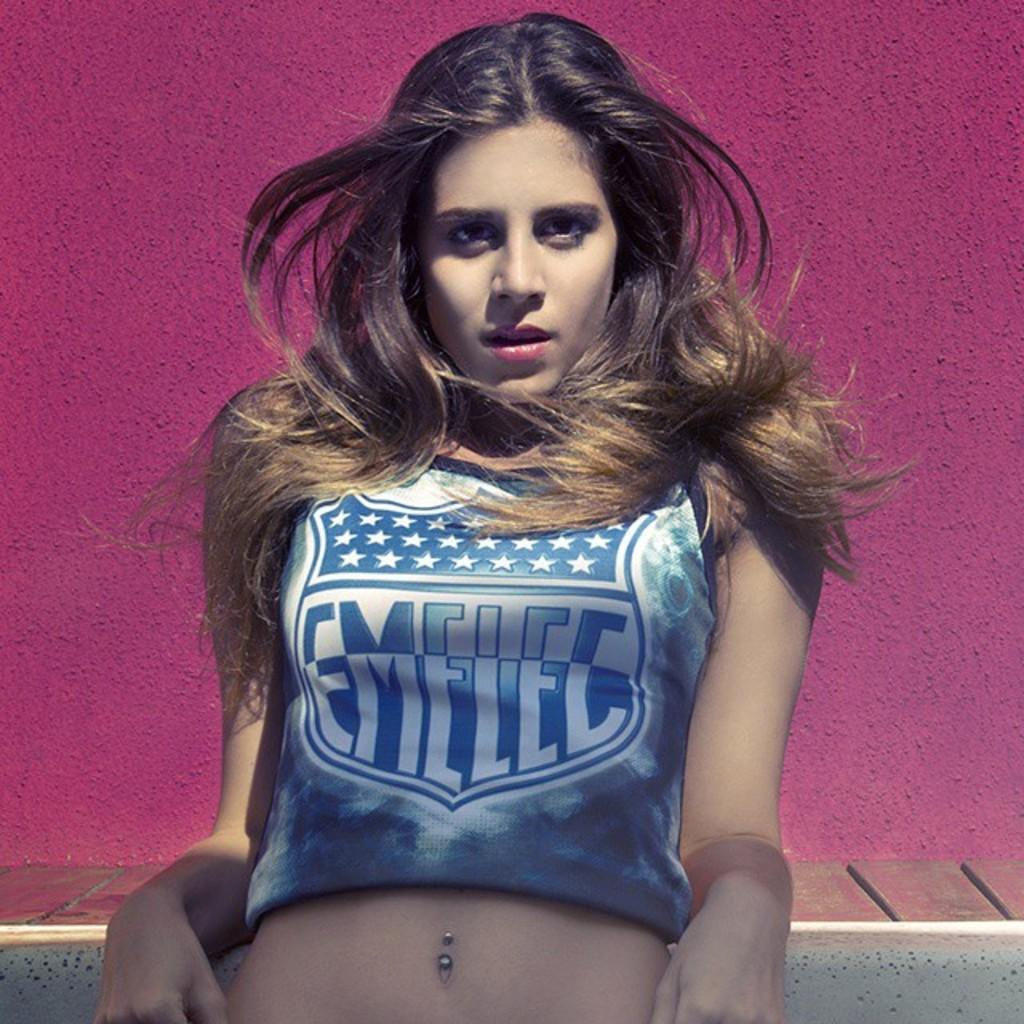Provide a one-sentence caption for the provided image. A women with long dark hair posing with a crop shirt with the logo Emelec along with a star pattern on the front. 